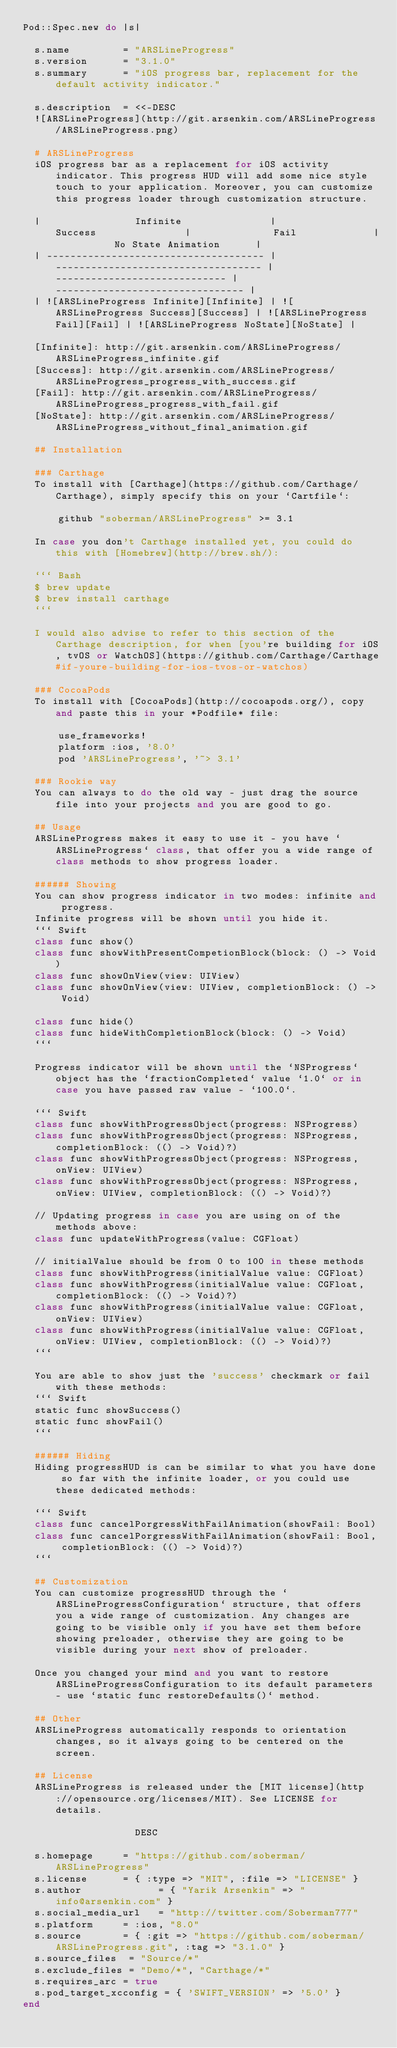Convert code to text. <code><loc_0><loc_0><loc_500><loc_500><_Ruby_>Pod::Spec.new do |s|

  s.name         = "ARSLineProgress"
  s.version      = "3.1.0"
  s.summary      = "iOS progress bar, replacement for the default activity indicator."

  s.description  = <<-DESC
  ![ARSLineProgress](http://git.arsenkin.com/ARSLineProgress/ARSLineProgress.png)

  # ARSLineProgress
  iOS progress bar as a replacement for iOS activity indicator. This progress HUD will add some nice style touch to your application. Moreover, you can customize this progress loader through customization structure.

  |                Infinite               |               Success               |              Fail             |          No State Animation      |
  | ------------------------------------- | ----------------------------------- | ----------------------------- | -------------------------------- |
  | ![ARSLineProgress Infinite][Infinite] | ![ARSLineProgress Success][Success] | ![ARSLineProgress Fail][Fail] | ![ARSLineProgress NoState][NoState] |

  [Infinite]: http://git.arsenkin.com/ARSLineProgress/ARSLineProgress_infinite.gif
  [Success]: http://git.arsenkin.com/ARSLineProgress/ARSLineProgress_progress_with_success.gif
  [Fail]: http://git.arsenkin.com/ARSLineProgress/ARSLineProgress_progress_with_fail.gif
  [NoState]: http://git.arsenkin.com/ARSLineProgress/ARSLineProgress_without_final_animation.gif

  ## Installation

  ### Carthage
  To install with [Carthage](https://github.com/Carthage/Carthage), simply specify this on your `Cartfile`:

      github "soberman/ARSLineProgress" >= 3.1

  In case you don't Carthage installed yet, you could do this with [Homebrew](http://brew.sh/):

  ``` Bash
  $ brew update
  $ brew install carthage
  ```

  I would also advise to refer to this section of the Carthage description, for when [you're building for iOS, tvOS or WatchOS](https://github.com/Carthage/Carthage#if-youre-building-for-ios-tvos-or-watchos)

  ### CocoaPods
  To install with [CocoaPods](http://cocoapods.org/), copy and paste this in your *Podfile* file:

      use_frameworks!
      platform :ios, '8.0'
      pod 'ARSLineProgress', '~> 3.1'

  ### Rookie way
  You can always to do the old way - just drag the source file into your projects and you are good to go.

  ## Usage
  ARSLineProgress makes it easy to use it - you have `ARSLineProgress` class, that offer you a wide range of class methods to show progress loader.

  ###### Showing
  You can show progress indicator in two modes: infinite and progress.
  Infinite progress will be shown until you hide it.
  ``` Swift
  class func show()
  class func showWithPresentCompetionBlock(block: () -> Void)
  class func showOnView(view: UIView)
  class func showOnView(view: UIView, completionBlock: () -> Void)

  class func hide()
  class func hideWithCompletionBlock(block: () -> Void)
  ```

  Progress indicator will be shown until the `NSProgress` object has the `fractionCompleted` value `1.0` or in case you have passed raw value - `100.0`.

  ``` Swift
  class func showWithProgressObject(progress: NSProgress)
  class func showWithProgressObject(progress: NSProgress, completionBlock: (() -> Void)?)
  class func showWithProgressObject(progress: NSProgress, onView: UIView)
  class func showWithProgressObject(progress: NSProgress, onView: UIView, completionBlock: (() -> Void)?)

  // Updating progress in case you are using on of the methods above:
  class func updateWithProgress(value: CGFloat)

  // initialValue should be from 0 to 100 in these methods
  class func showWithProgress(initialValue value: CGFloat)
  class func showWithProgress(initialValue value: CGFloat, completionBlock: (() -> Void)?)
  class func showWithProgress(initialValue value: CGFloat, onView: UIView)
  class func showWithProgress(initialValue value: CGFloat, onView: UIView, completionBlock: (() -> Void)?)
  ```

  You are able to show just the 'success' checkmark or fail with these methods:
  ``` Swift
  static func showSuccess()
  static func showFail()
  ```

  ###### Hiding
  Hiding progressHUD is can be similar to what you have done so far with the infinite loader, or you could use these dedicated methods:

  ``` Swift
  class func cancelPorgressWithFailAnimation(showFail: Bool)
  class func cancelPorgressWithFailAnimation(showFail: Bool, completionBlock: (() -> Void)?)
  ```

  ## Customization
  You can customize progressHUD through the `ARSLineProgressConfiguration` structure, that offers you a wide range of customization. Any changes are going to be visible only if you have set them before showing preloader, otherwise they are going to be visible during your next show of preloader.

  Once you changed your mind and you want to restore ARSLineProgressConfiguration to its default parameters - use `static func restoreDefaults()` method.

  ## Other
  ARSLineProgress automatically responds to orientation changes, so it always going to be centered on the screen.

  ## License
  ARSLineProgress is released under the [MIT license](http://opensource.org/licenses/MIT). See LICENSE for details.

                   DESC

  s.homepage     = "https://github.com/soberman/ARSLineProgress"
  s.license      = { :type => "MIT", :file => "LICENSE" }
  s.author             = { "Yarik Arsenkin" => "info@arsenkin.com" }
  s.social_media_url   = "http://twitter.com/Soberman777"
  s.platform     = :ios, "8.0"
  s.source       = { :git => "https://github.com/soberman/ARSLineProgress.git", :tag => "3.1.0" }
  s.source_files  = "Source/*"
  s.exclude_files = "Demo/*", "Carthage/*"
  s.requires_arc = true
  s.pod_target_xcconfig = { 'SWIFT_VERSION' => '5.0' }
end
</code> 